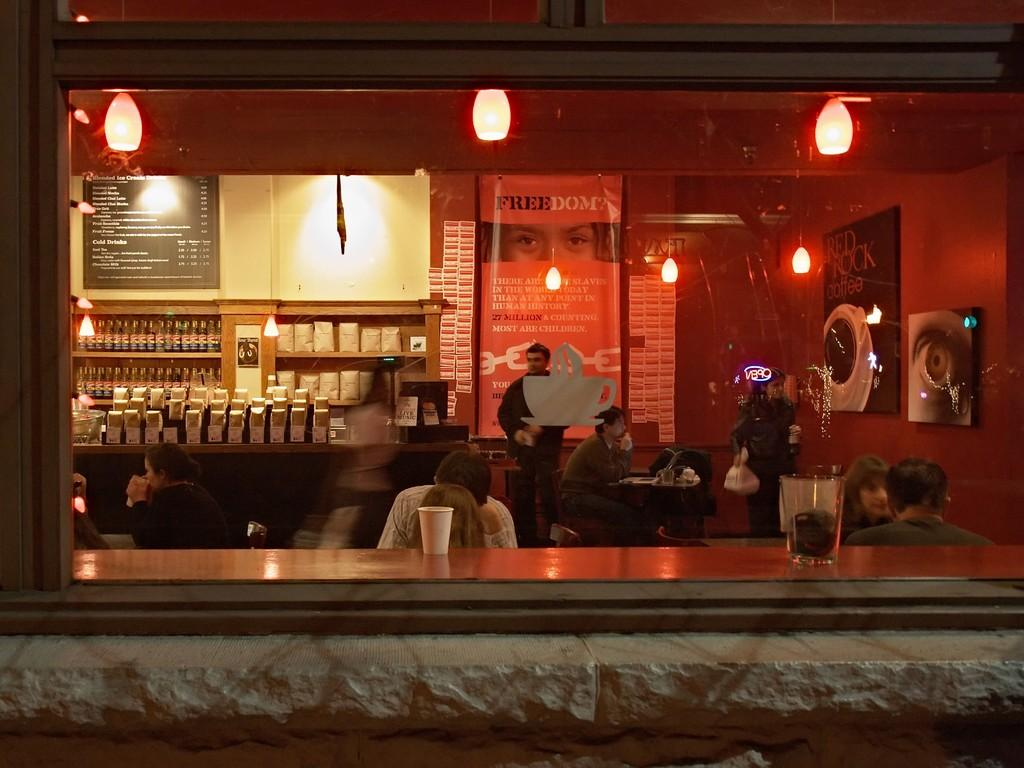What type of space is depicted in the image? There is a room in the image. What are the people in the room doing? The people are sitting in the room and drinking coffee. What can be seen in the background of the image? There are bottles, packets, a menu board, banners, and light visible in the background. What type of kite is being flown by the manager in the image? There is no kite or manager present in the image. What color is the neck of the person sitting in the room? The provided facts do not mention the color of anyone's neck, so it cannot be determined from the image. 